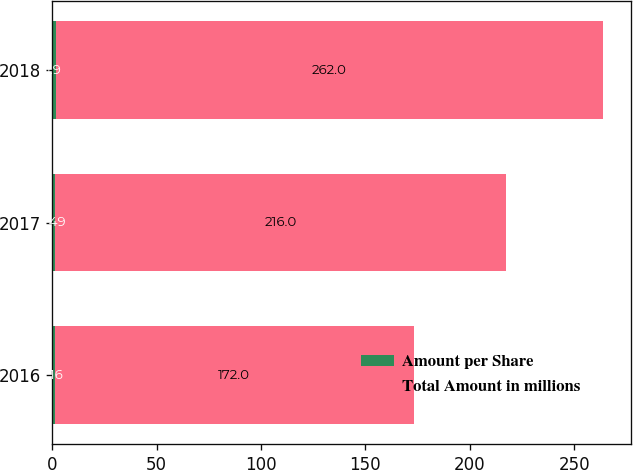Convert chart to OTSL. <chart><loc_0><loc_0><loc_500><loc_500><stacked_bar_chart><ecel><fcel>2016<fcel>2017<fcel>2018<nl><fcel>Amount per Share<fcel>1.16<fcel>1.49<fcel>1.9<nl><fcel>Total Amount in millions<fcel>172<fcel>216<fcel>262<nl></chart> 